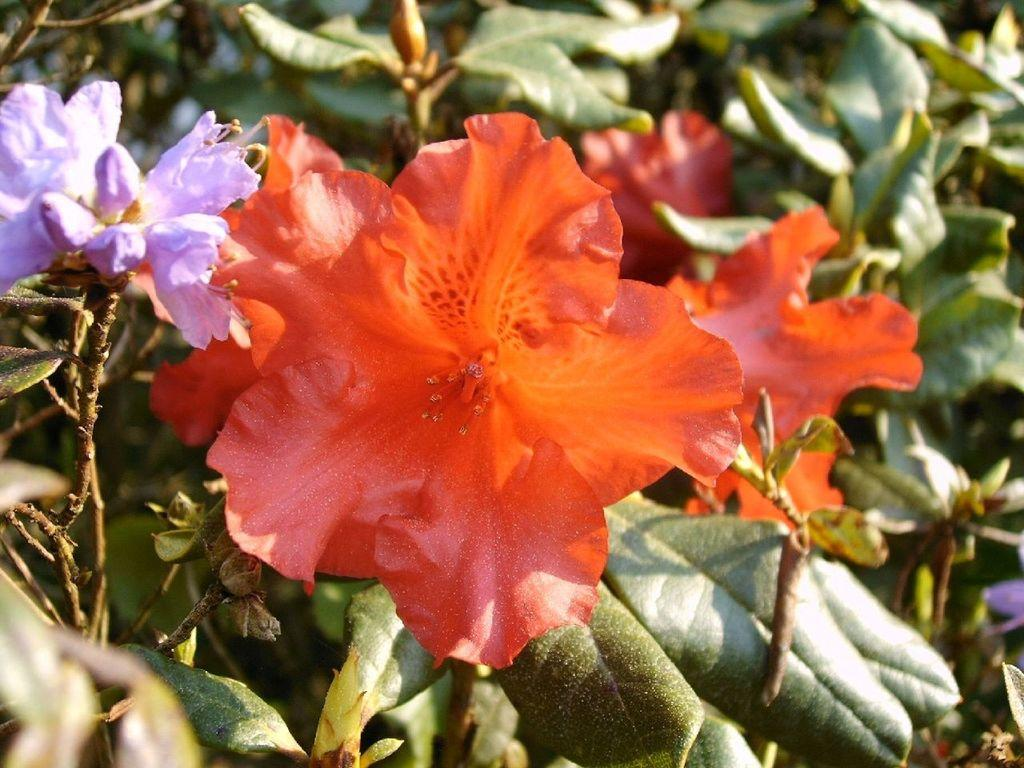What type of living organisms can be seen in the image? Plants can be seen in the image. What specific feature of the plants is mentioned in the facts? The plants have colorful flowers. Can you see any cobwebs on the plants in the image? There is no mention of cobwebs in the image, so it cannot be determined if any are present. What type of ornament is hanging from the flowers in the image? There is no mention of any ornaments hanging from the flowers in the image. 